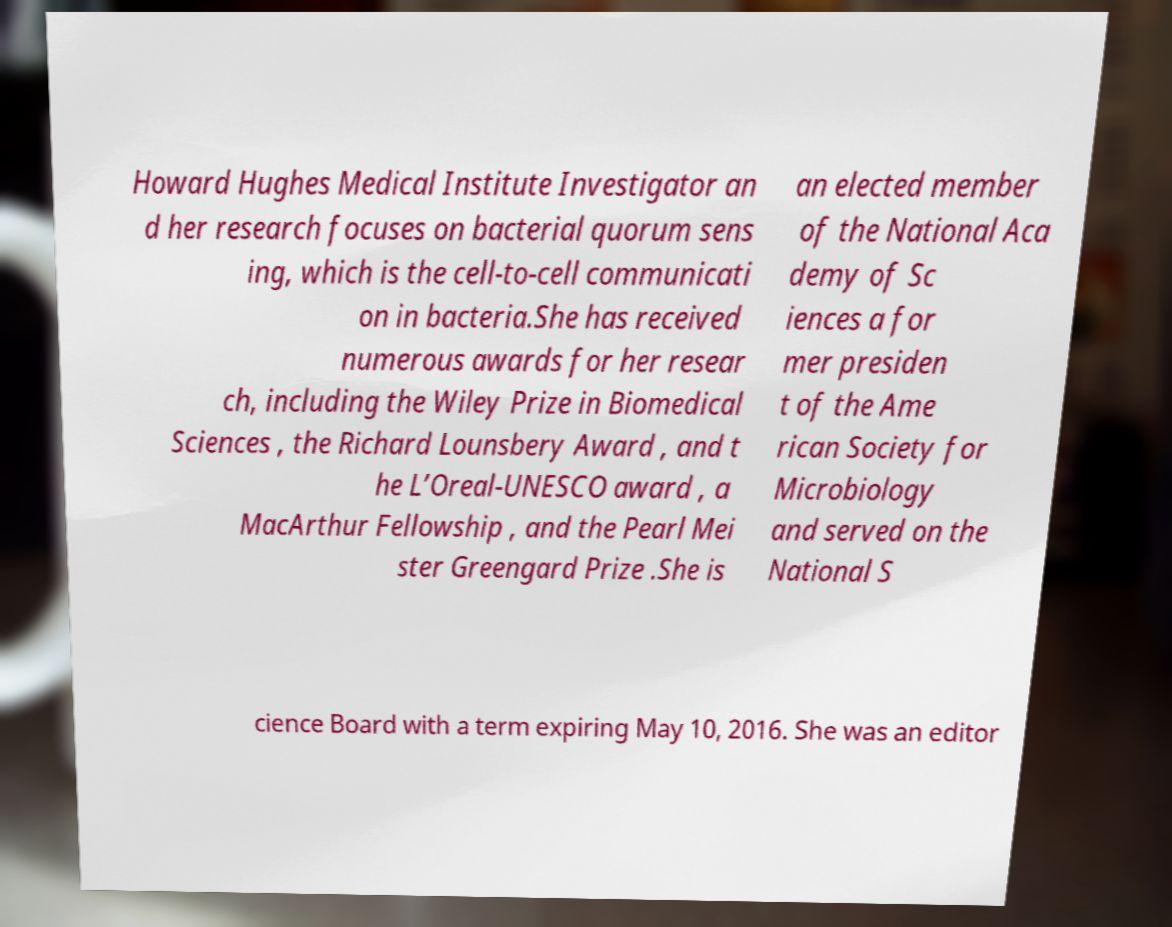For documentation purposes, I need the text within this image transcribed. Could you provide that? Howard Hughes Medical Institute Investigator an d her research focuses on bacterial quorum sens ing, which is the cell-to-cell communicati on in bacteria.She has received numerous awards for her resear ch, including the Wiley Prize in Biomedical Sciences , the Richard Lounsbery Award , and t he L’Oreal-UNESCO award , a MacArthur Fellowship , and the Pearl Mei ster Greengard Prize .She is an elected member of the National Aca demy of Sc iences a for mer presiden t of the Ame rican Society for Microbiology and served on the National S cience Board with a term expiring May 10, 2016. She was an editor 